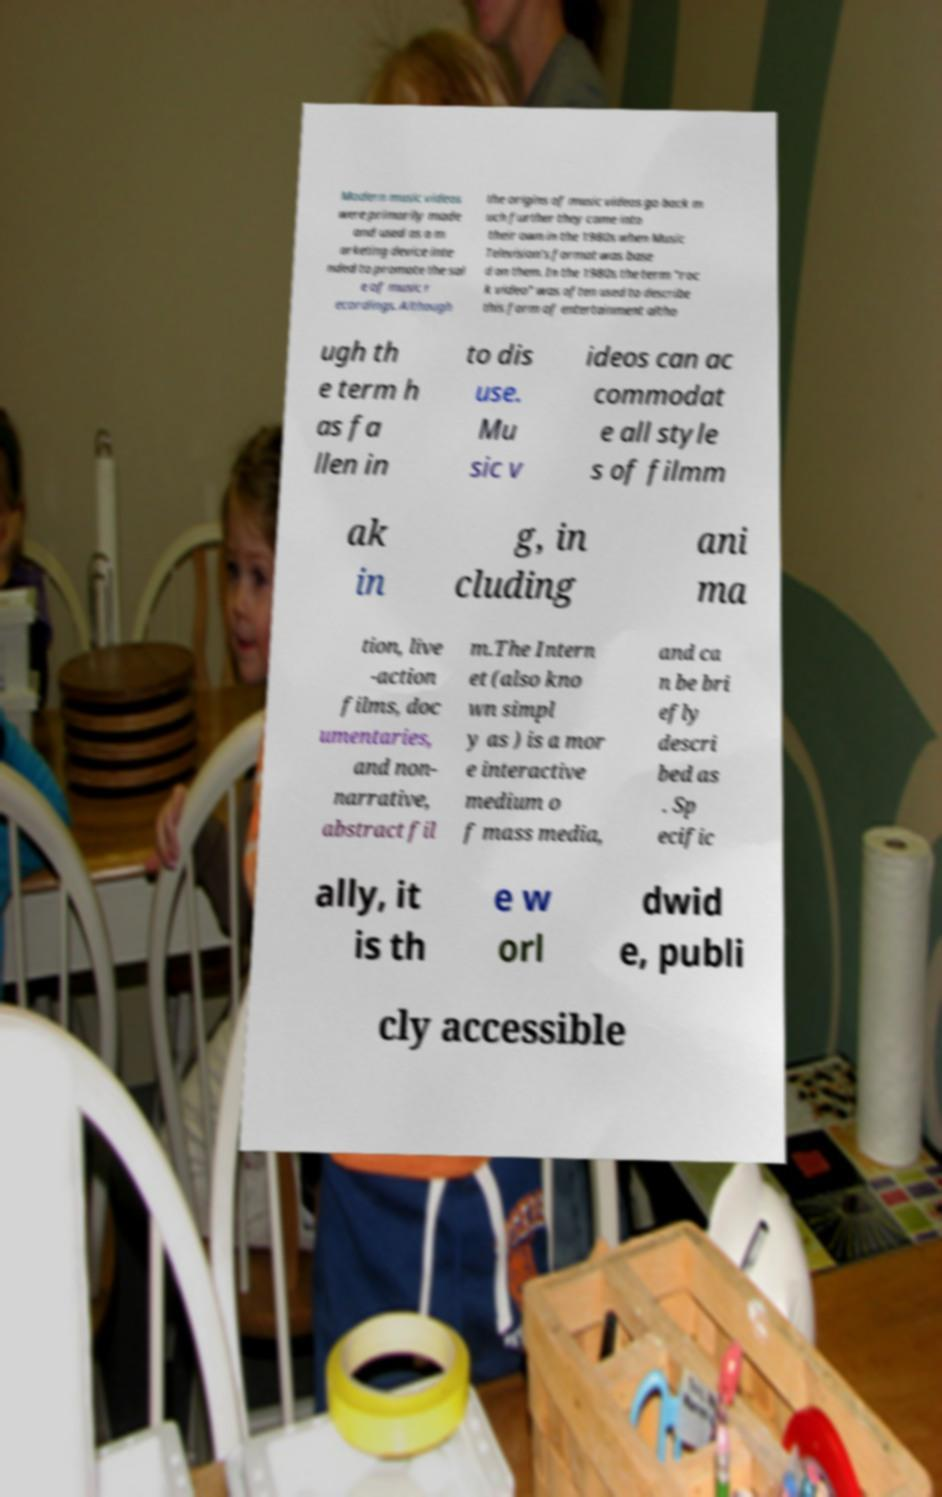Can you read and provide the text displayed in the image?This photo seems to have some interesting text. Can you extract and type it out for me? Modern music videos were primarily made and used as a m arketing device inte nded to promote the sal e of music r ecordings. Although the origins of music videos go back m uch further they came into their own in the 1980s when Music Television's format was base d on them. In the 1980s the term "roc k video" was often used to describe this form of entertainment altho ugh th e term h as fa llen in to dis use. Mu sic v ideos can ac commodat e all style s of filmm ak in g, in cluding ani ma tion, live -action films, doc umentaries, and non- narrative, abstract fil m.The Intern et (also kno wn simpl y as ) is a mor e interactive medium o f mass media, and ca n be bri efly descri bed as . Sp ecific ally, it is th e w orl dwid e, publi cly accessible 